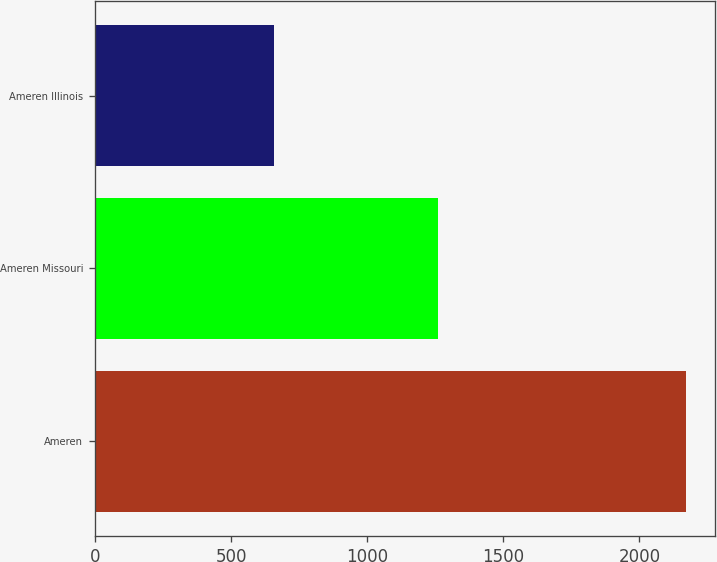Convert chart. <chart><loc_0><loc_0><loc_500><loc_500><bar_chart><fcel>Ameren<fcel>Ameren Missouri<fcel>Ameren Illinois<nl><fcel>2170<fcel>1260<fcel>659<nl></chart> 